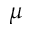<formula> <loc_0><loc_0><loc_500><loc_500>\mu</formula> 